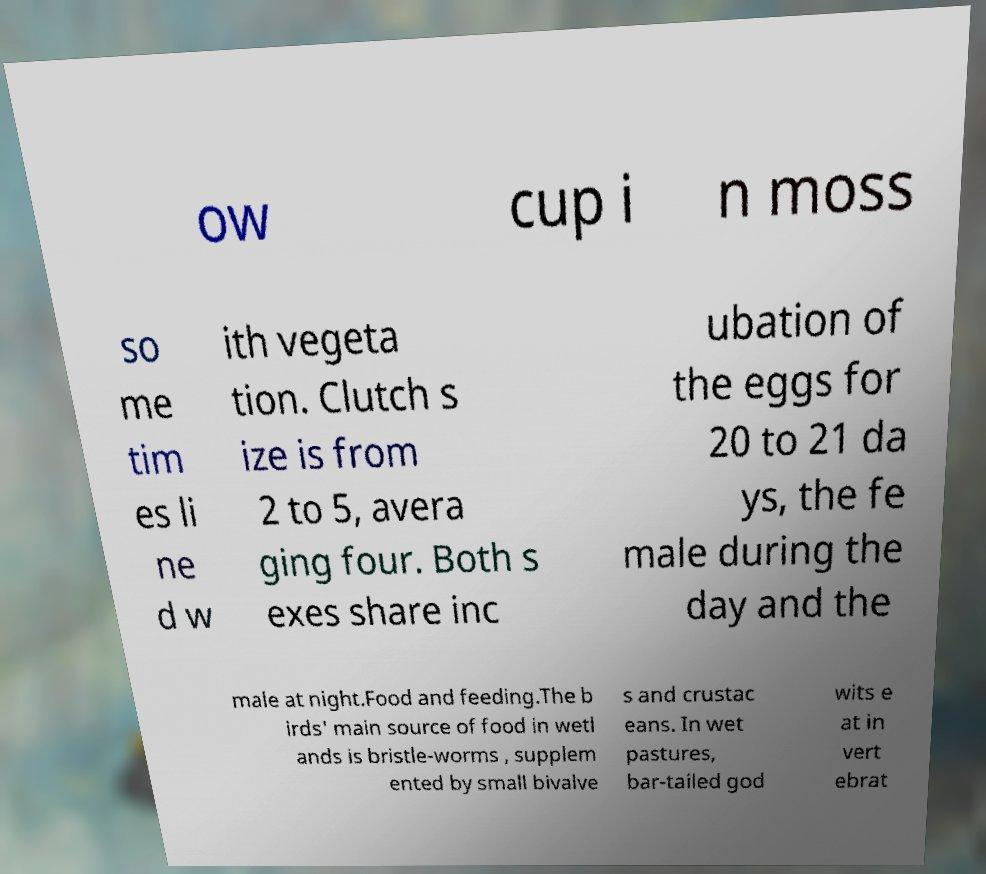I need the written content from this picture converted into text. Can you do that? ow cup i n moss so me tim es li ne d w ith vegeta tion. Clutch s ize is from 2 to 5, avera ging four. Both s exes share inc ubation of the eggs for 20 to 21 da ys, the fe male during the day and the male at night.Food and feeding.The b irds' main source of food in wetl ands is bristle-worms , supplem ented by small bivalve s and crustac eans. In wet pastures, bar-tailed god wits e at in vert ebrat 